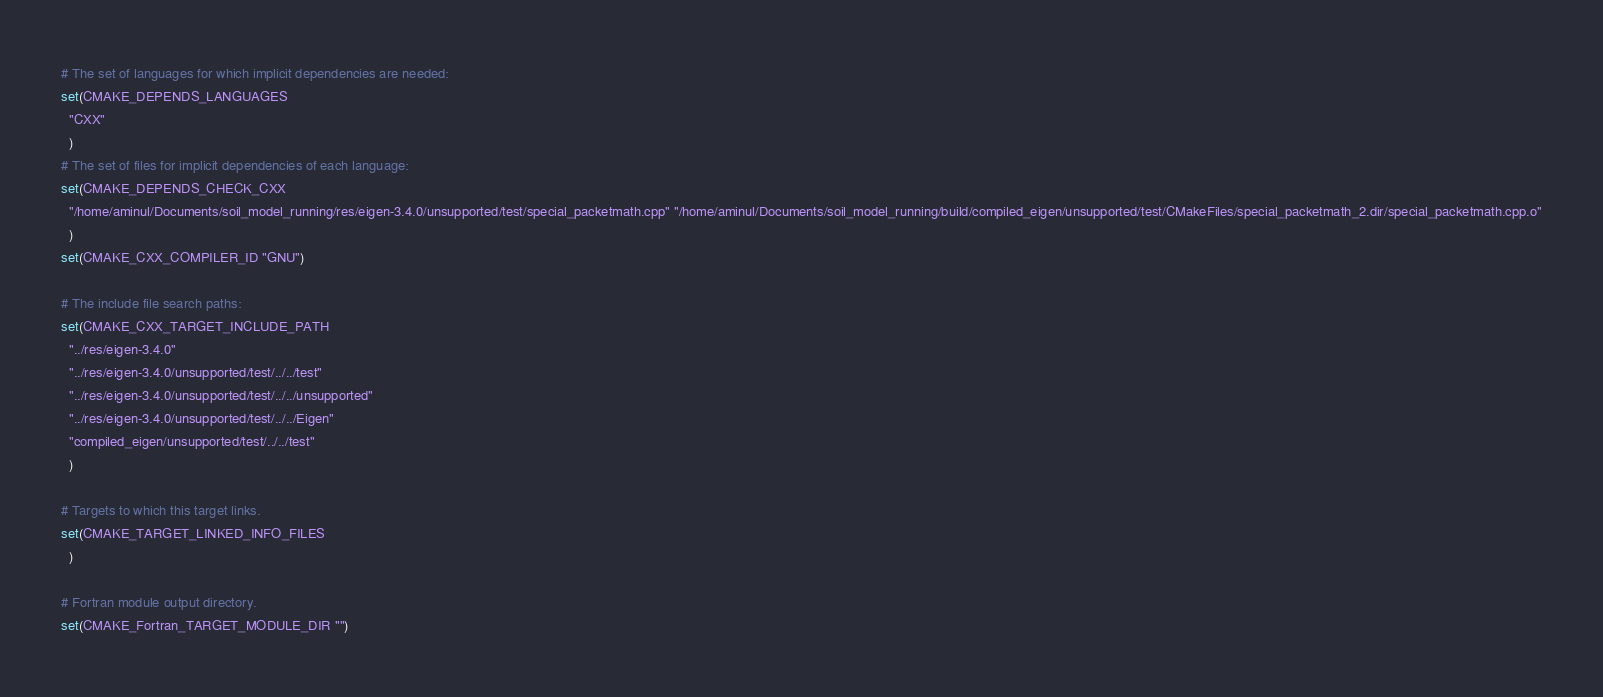<code> <loc_0><loc_0><loc_500><loc_500><_CMake_># The set of languages for which implicit dependencies are needed:
set(CMAKE_DEPENDS_LANGUAGES
  "CXX"
  )
# The set of files for implicit dependencies of each language:
set(CMAKE_DEPENDS_CHECK_CXX
  "/home/aminul/Documents/soil_model_running/res/eigen-3.4.0/unsupported/test/special_packetmath.cpp" "/home/aminul/Documents/soil_model_running/build/compiled_eigen/unsupported/test/CMakeFiles/special_packetmath_2.dir/special_packetmath.cpp.o"
  )
set(CMAKE_CXX_COMPILER_ID "GNU")

# The include file search paths:
set(CMAKE_CXX_TARGET_INCLUDE_PATH
  "../res/eigen-3.4.0"
  "../res/eigen-3.4.0/unsupported/test/../../test"
  "../res/eigen-3.4.0/unsupported/test/../../unsupported"
  "../res/eigen-3.4.0/unsupported/test/../../Eigen"
  "compiled_eigen/unsupported/test/../../test"
  )

# Targets to which this target links.
set(CMAKE_TARGET_LINKED_INFO_FILES
  )

# Fortran module output directory.
set(CMAKE_Fortran_TARGET_MODULE_DIR "")
</code> 